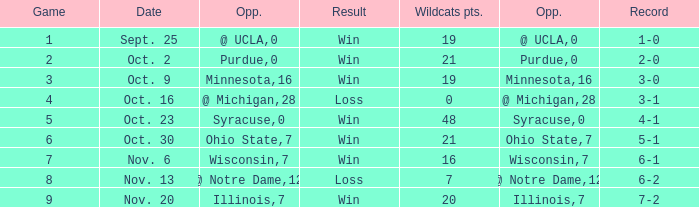What is the lowest points scored by the Wildcats when the record was 5-1? 21.0. Would you be able to parse every entry in this table? {'header': ['Game', 'Date', 'Opp.', 'Result', 'Wildcats pts.', 'Opp.', 'Record'], 'rows': [['1', 'Sept. 25', '@ UCLA', 'Win', '19', '0', '1-0'], ['2', 'Oct. 2', 'Purdue', 'Win', '21', '0', '2-0'], ['3', 'Oct. 9', 'Minnesota', 'Win', '19', '16', '3-0'], ['4', 'Oct. 16', '@ Michigan', 'Loss', '0', '28', '3-1'], ['5', 'Oct. 23', 'Syracuse', 'Win', '48', '0', '4-1'], ['6', 'Oct. 30', 'Ohio State', 'Win', '21', '7', '5-1'], ['7', 'Nov. 6', 'Wisconsin', 'Win', '16', '7', '6-1'], ['8', 'Nov. 13', '@ Notre Dame', 'Loss', '7', '12', '6-2'], ['9', 'Nov. 20', 'Illinois', 'Win', '20', '7', '7-2']]} 